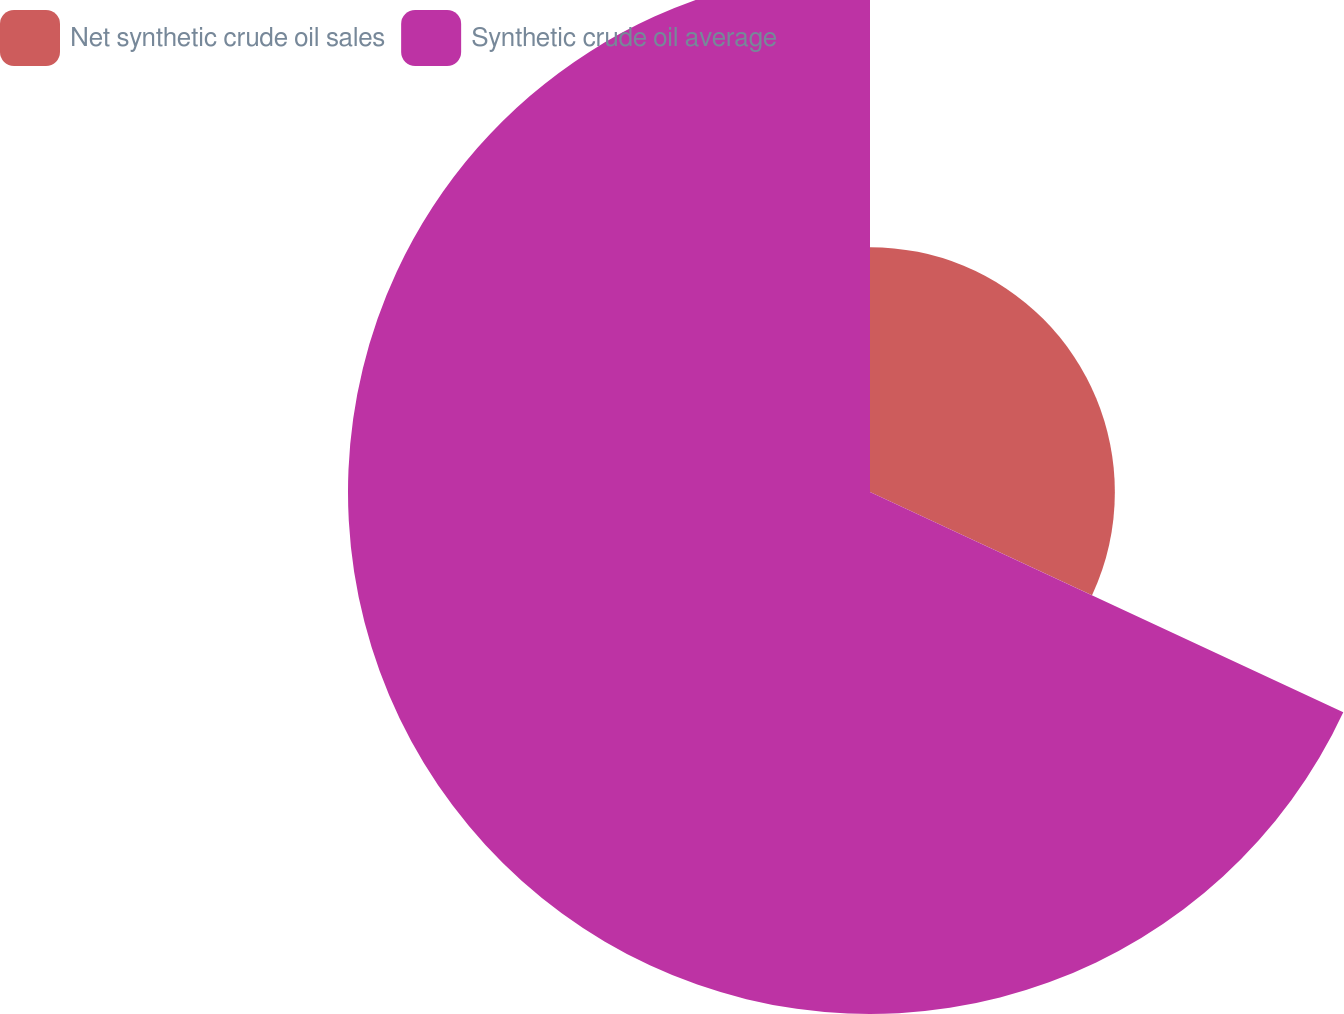<chart> <loc_0><loc_0><loc_500><loc_500><pie_chart><fcel>Net synthetic crude oil sales<fcel>Synthetic crude oil average<nl><fcel>31.93%<fcel>68.07%<nl></chart> 